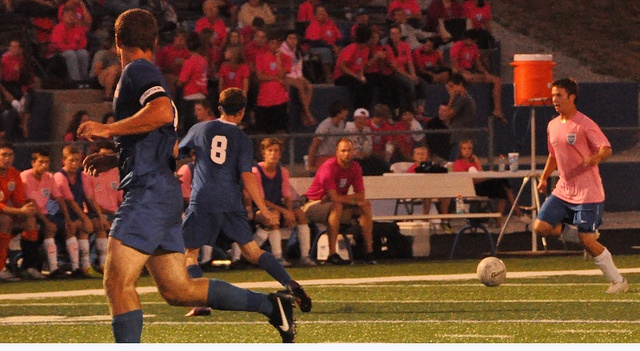Describe the objects in this image and their specific colors. I can see people in black, maroon, and brown tones, people in black, brown, and maroon tones, people in black, brown, gray, and maroon tones, people in black, salmon, and brown tones, and people in black, maroon, and brown tones in this image. 